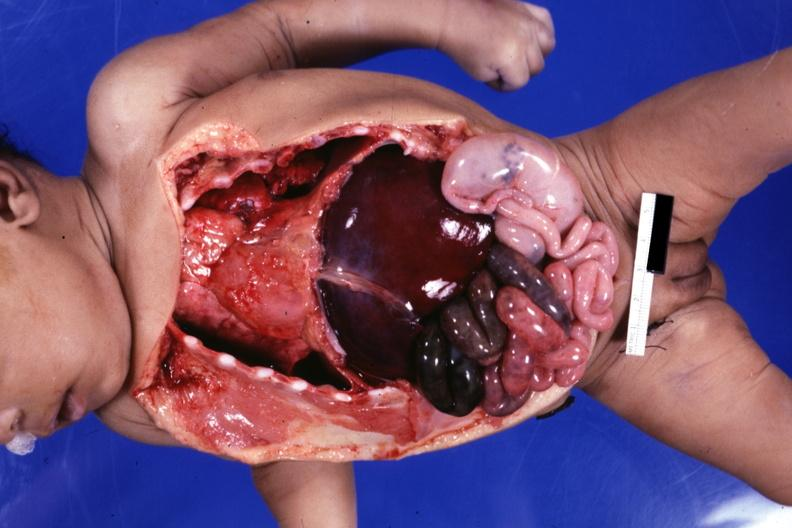how is infant body opened showing apex to right?
Answer the question using a single word or phrase. Cardiac 